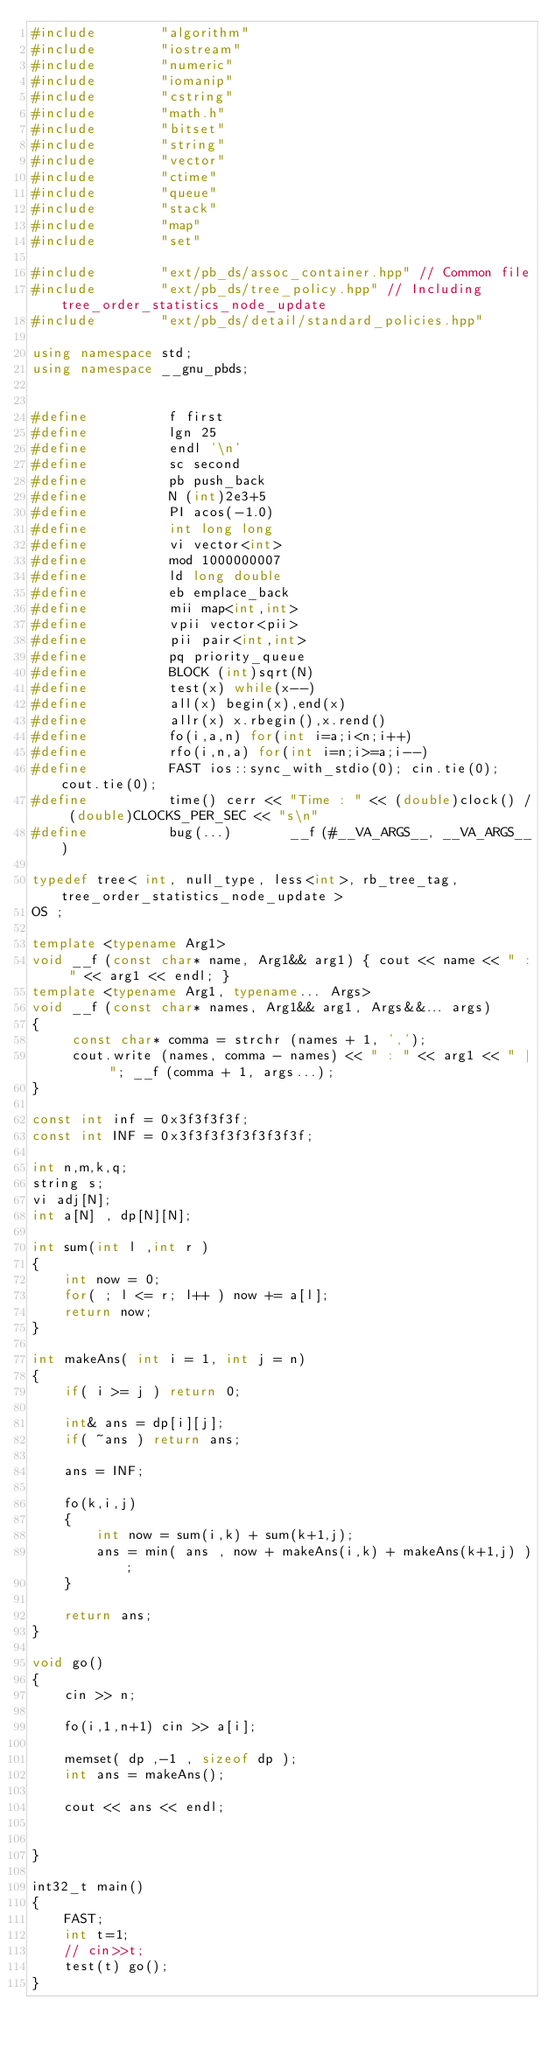<code> <loc_0><loc_0><loc_500><loc_500><_C++_>#include        "algorithm"
#include        "iostream"
#include        "numeric"
#include        "iomanip"
#include        "cstring"
#include        "math.h"
#include        "bitset"
#include        "string"
#include        "vector"
#include        "ctime"
#include        "queue"
#include        "stack"
#include        "map"
#include        "set"

#include        "ext/pb_ds/assoc_container.hpp" // Common file
#include        "ext/pb_ds/tree_policy.hpp" // Including tree_order_statistics_node_update
#include        "ext/pb_ds/detail/standard_policies.hpp"

using namespace std;
using namespace __gnu_pbds;


#define          f first
#define          lgn 25
#define          endl '\n'
#define          sc second
#define          pb push_back
#define          N (int)2e3+5
#define          PI acos(-1.0)
#define          int long long 
#define          vi vector<int>
#define          mod 1000000007
#define          ld long double
#define          eb emplace_back
#define          mii map<int,int>
#define          vpii vector<pii>
#define          pii pair<int,int>
#define          pq priority_queue
#define          BLOCK (int)sqrt(N)
#define          test(x) while(x--)
#define          all(x) begin(x),end(x)
#define          allr(x) x.rbegin(),x.rend()
#define          fo(i,a,n) for(int i=a;i<n;i++)
#define          rfo(i,n,a) for(int i=n;i>=a;i--)
#define          FAST ios::sync_with_stdio(0); cin.tie(0); cout.tie(0);
#define          time() cerr << "Time : " << (double)clock() / (double)CLOCKS_PER_SEC << "s\n"
#define 		 bug(...)       __f (#__VA_ARGS__, __VA_ARGS__)

typedef tree< int, null_type, less<int>, rb_tree_tag, tree_order_statistics_node_update > 
OS ;

template <typename Arg1>
void __f (const char* name, Arg1&& arg1) { cout << name << " : " << arg1 << endl; }
template <typename Arg1, typename... Args>
void __f (const char* names, Arg1&& arg1, Args&&... args)
{
     const char* comma = strchr (names + 1, ',');
     cout.write (names, comma - names) << " : " << arg1 << " | "; __f (comma + 1, args...);
}

const int inf = 0x3f3f3f3f;
const int INF = 0x3f3f3f3f3f3f3f3f;

int n,m,k,q;
string s;
vi adj[N];
int a[N] , dp[N][N];

int sum(int l ,int r ) 
{
	int now = 0;	
	for( ; l <= r; l++ ) now += a[l];
	return now;
}

int makeAns( int i = 1, int j = n)
{
	if( i >= j ) return 0;

	int& ans = dp[i][j];
	if( ~ans ) return ans;

	ans = INF;

	fo(k,i,j)
	{
		int now = sum(i,k) + sum(k+1,j);
		ans = min( ans , now + makeAns(i,k) + makeAns(k+1,j) );
	}

	return ans;
}

void go()
{
	cin >> n;

	fo(i,1,n+1) cin >> a[i];

	memset( dp ,-1 , sizeof dp );
	int ans = makeAns();

	cout << ans << endl;


}

int32_t main()
{
	FAST;     
	int t=1; 
	// cin>>t;
	test(t) go();
}

</code> 